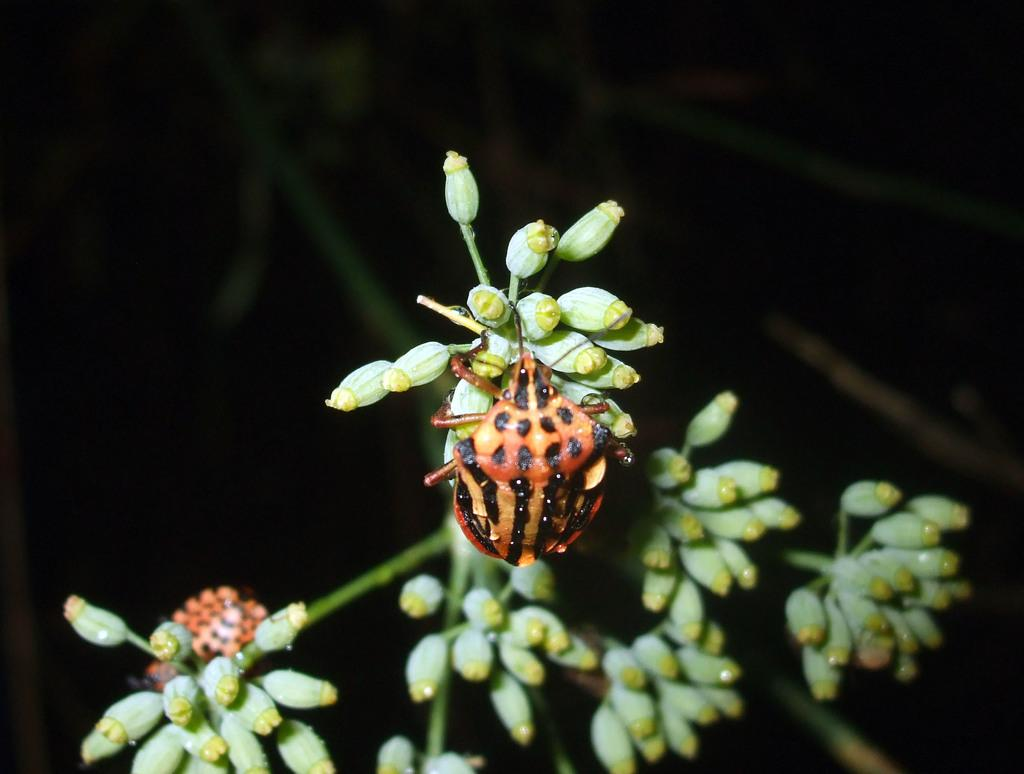What type of creature is in the image? There is an insect in the image. Where is the insect located? The insect is on a plant. What color is the background of the image? The background of the image appears to be black. What decision did the insect make in the image? There is no indication of the insect making a decision in the image. What stage of development is the insect in the image? The image does not provide enough information to determine the insect's stage of development. 